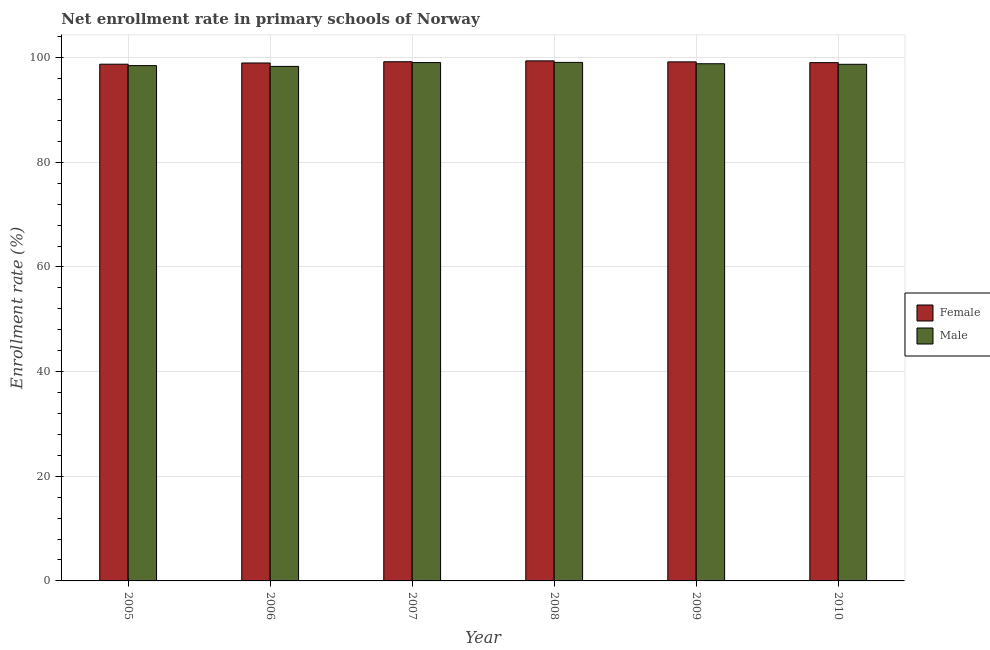How many different coloured bars are there?
Ensure brevity in your answer.  2. What is the enrollment rate of female students in 2006?
Your response must be concise. 98.97. Across all years, what is the maximum enrollment rate of female students?
Your response must be concise. 99.38. Across all years, what is the minimum enrollment rate of male students?
Make the answer very short. 98.32. In which year was the enrollment rate of female students maximum?
Provide a succinct answer. 2008. In which year was the enrollment rate of male students minimum?
Offer a terse response. 2006. What is the total enrollment rate of male students in the graph?
Offer a very short reply. 592.49. What is the difference between the enrollment rate of male students in 2006 and that in 2009?
Your response must be concise. -0.51. What is the difference between the enrollment rate of female students in 2009 and the enrollment rate of male students in 2006?
Offer a very short reply. 0.21. What is the average enrollment rate of male students per year?
Give a very brief answer. 98.75. In the year 2007, what is the difference between the enrollment rate of female students and enrollment rate of male students?
Ensure brevity in your answer.  0. In how many years, is the enrollment rate of male students greater than 60 %?
Offer a terse response. 6. What is the ratio of the enrollment rate of female students in 2005 to that in 2009?
Ensure brevity in your answer.  1. Is the enrollment rate of male students in 2005 less than that in 2010?
Give a very brief answer. Yes. Is the difference between the enrollment rate of female students in 2007 and 2009 greater than the difference between the enrollment rate of male students in 2007 and 2009?
Provide a short and direct response. No. What is the difference between the highest and the second highest enrollment rate of male students?
Offer a terse response. 0.03. What is the difference between the highest and the lowest enrollment rate of male students?
Offer a terse response. 0.76. Is the sum of the enrollment rate of female students in 2005 and 2008 greater than the maximum enrollment rate of male students across all years?
Offer a very short reply. Yes. What does the 2nd bar from the left in 2010 represents?
Your answer should be very brief. Male. What does the 2nd bar from the right in 2005 represents?
Make the answer very short. Female. Are all the bars in the graph horizontal?
Keep it short and to the point. No. Does the graph contain any zero values?
Provide a succinct answer. No. What is the title of the graph?
Provide a short and direct response. Net enrollment rate in primary schools of Norway. What is the label or title of the X-axis?
Make the answer very short. Year. What is the label or title of the Y-axis?
Your answer should be compact. Enrollment rate (%). What is the Enrollment rate (%) of Female in 2005?
Your response must be concise. 98.74. What is the Enrollment rate (%) in Male in 2005?
Ensure brevity in your answer.  98.47. What is the Enrollment rate (%) of Female in 2006?
Make the answer very short. 98.97. What is the Enrollment rate (%) in Male in 2006?
Provide a short and direct response. 98.32. What is the Enrollment rate (%) of Female in 2007?
Offer a very short reply. 99.21. What is the Enrollment rate (%) of Male in 2007?
Make the answer very short. 99.05. What is the Enrollment rate (%) of Female in 2008?
Offer a terse response. 99.38. What is the Enrollment rate (%) of Male in 2008?
Offer a very short reply. 99.09. What is the Enrollment rate (%) in Female in 2009?
Ensure brevity in your answer.  99.19. What is the Enrollment rate (%) of Male in 2009?
Give a very brief answer. 98.83. What is the Enrollment rate (%) in Female in 2010?
Your answer should be very brief. 99.04. What is the Enrollment rate (%) in Male in 2010?
Your answer should be compact. 98.72. Across all years, what is the maximum Enrollment rate (%) of Female?
Ensure brevity in your answer.  99.38. Across all years, what is the maximum Enrollment rate (%) in Male?
Provide a short and direct response. 99.09. Across all years, what is the minimum Enrollment rate (%) in Female?
Provide a short and direct response. 98.74. Across all years, what is the minimum Enrollment rate (%) in Male?
Offer a very short reply. 98.32. What is the total Enrollment rate (%) in Female in the graph?
Keep it short and to the point. 594.53. What is the total Enrollment rate (%) of Male in the graph?
Keep it short and to the point. 592.49. What is the difference between the Enrollment rate (%) of Female in 2005 and that in 2006?
Your answer should be very brief. -0.23. What is the difference between the Enrollment rate (%) of Male in 2005 and that in 2006?
Your answer should be compact. 0.15. What is the difference between the Enrollment rate (%) in Female in 2005 and that in 2007?
Provide a succinct answer. -0.47. What is the difference between the Enrollment rate (%) of Male in 2005 and that in 2007?
Your response must be concise. -0.58. What is the difference between the Enrollment rate (%) of Female in 2005 and that in 2008?
Keep it short and to the point. -0.64. What is the difference between the Enrollment rate (%) of Male in 2005 and that in 2008?
Provide a succinct answer. -0.61. What is the difference between the Enrollment rate (%) in Female in 2005 and that in 2009?
Your answer should be compact. -0.45. What is the difference between the Enrollment rate (%) of Male in 2005 and that in 2009?
Ensure brevity in your answer.  -0.36. What is the difference between the Enrollment rate (%) of Female in 2005 and that in 2010?
Give a very brief answer. -0.3. What is the difference between the Enrollment rate (%) of Male in 2005 and that in 2010?
Your response must be concise. -0.25. What is the difference between the Enrollment rate (%) in Female in 2006 and that in 2007?
Your answer should be very brief. -0.24. What is the difference between the Enrollment rate (%) of Male in 2006 and that in 2007?
Keep it short and to the point. -0.73. What is the difference between the Enrollment rate (%) of Female in 2006 and that in 2008?
Make the answer very short. -0.4. What is the difference between the Enrollment rate (%) in Male in 2006 and that in 2008?
Provide a short and direct response. -0.76. What is the difference between the Enrollment rate (%) in Female in 2006 and that in 2009?
Your response must be concise. -0.21. What is the difference between the Enrollment rate (%) of Male in 2006 and that in 2009?
Offer a terse response. -0.51. What is the difference between the Enrollment rate (%) of Female in 2006 and that in 2010?
Offer a very short reply. -0.07. What is the difference between the Enrollment rate (%) of Male in 2006 and that in 2010?
Your answer should be compact. -0.4. What is the difference between the Enrollment rate (%) in Female in 2007 and that in 2008?
Keep it short and to the point. -0.17. What is the difference between the Enrollment rate (%) in Male in 2007 and that in 2008?
Give a very brief answer. -0.03. What is the difference between the Enrollment rate (%) of Female in 2007 and that in 2009?
Ensure brevity in your answer.  0.02. What is the difference between the Enrollment rate (%) of Male in 2007 and that in 2009?
Your answer should be compact. 0.22. What is the difference between the Enrollment rate (%) of Female in 2007 and that in 2010?
Offer a very short reply. 0.17. What is the difference between the Enrollment rate (%) in Male in 2007 and that in 2010?
Your response must be concise. 0.33. What is the difference between the Enrollment rate (%) of Female in 2008 and that in 2009?
Offer a very short reply. 0.19. What is the difference between the Enrollment rate (%) of Male in 2008 and that in 2009?
Make the answer very short. 0.26. What is the difference between the Enrollment rate (%) in Female in 2008 and that in 2010?
Ensure brevity in your answer.  0.34. What is the difference between the Enrollment rate (%) of Male in 2008 and that in 2010?
Your response must be concise. 0.36. What is the difference between the Enrollment rate (%) of Female in 2009 and that in 2010?
Your answer should be very brief. 0.15. What is the difference between the Enrollment rate (%) of Male in 2009 and that in 2010?
Your answer should be compact. 0.11. What is the difference between the Enrollment rate (%) in Female in 2005 and the Enrollment rate (%) in Male in 2006?
Your response must be concise. 0.42. What is the difference between the Enrollment rate (%) of Female in 2005 and the Enrollment rate (%) of Male in 2007?
Make the answer very short. -0.31. What is the difference between the Enrollment rate (%) in Female in 2005 and the Enrollment rate (%) in Male in 2008?
Give a very brief answer. -0.34. What is the difference between the Enrollment rate (%) in Female in 2005 and the Enrollment rate (%) in Male in 2009?
Offer a very short reply. -0.09. What is the difference between the Enrollment rate (%) in Female in 2005 and the Enrollment rate (%) in Male in 2010?
Your response must be concise. 0.02. What is the difference between the Enrollment rate (%) of Female in 2006 and the Enrollment rate (%) of Male in 2007?
Your answer should be very brief. -0.08. What is the difference between the Enrollment rate (%) in Female in 2006 and the Enrollment rate (%) in Male in 2008?
Offer a very short reply. -0.11. What is the difference between the Enrollment rate (%) in Female in 2006 and the Enrollment rate (%) in Male in 2009?
Provide a short and direct response. 0.14. What is the difference between the Enrollment rate (%) in Female in 2006 and the Enrollment rate (%) in Male in 2010?
Keep it short and to the point. 0.25. What is the difference between the Enrollment rate (%) in Female in 2007 and the Enrollment rate (%) in Male in 2008?
Ensure brevity in your answer.  0.13. What is the difference between the Enrollment rate (%) of Female in 2007 and the Enrollment rate (%) of Male in 2009?
Ensure brevity in your answer.  0.38. What is the difference between the Enrollment rate (%) of Female in 2007 and the Enrollment rate (%) of Male in 2010?
Give a very brief answer. 0.49. What is the difference between the Enrollment rate (%) of Female in 2008 and the Enrollment rate (%) of Male in 2009?
Offer a very short reply. 0.55. What is the difference between the Enrollment rate (%) of Female in 2008 and the Enrollment rate (%) of Male in 2010?
Keep it short and to the point. 0.65. What is the difference between the Enrollment rate (%) of Female in 2009 and the Enrollment rate (%) of Male in 2010?
Give a very brief answer. 0.46. What is the average Enrollment rate (%) of Female per year?
Provide a short and direct response. 99.09. What is the average Enrollment rate (%) of Male per year?
Ensure brevity in your answer.  98.75. In the year 2005, what is the difference between the Enrollment rate (%) of Female and Enrollment rate (%) of Male?
Your answer should be compact. 0.27. In the year 2006, what is the difference between the Enrollment rate (%) in Female and Enrollment rate (%) in Male?
Provide a short and direct response. 0.65. In the year 2007, what is the difference between the Enrollment rate (%) in Female and Enrollment rate (%) in Male?
Make the answer very short. 0.16. In the year 2008, what is the difference between the Enrollment rate (%) in Female and Enrollment rate (%) in Male?
Your response must be concise. 0.29. In the year 2009, what is the difference between the Enrollment rate (%) of Female and Enrollment rate (%) of Male?
Ensure brevity in your answer.  0.36. In the year 2010, what is the difference between the Enrollment rate (%) of Female and Enrollment rate (%) of Male?
Your answer should be very brief. 0.32. What is the ratio of the Enrollment rate (%) in Male in 2005 to that in 2006?
Ensure brevity in your answer.  1. What is the ratio of the Enrollment rate (%) in Male in 2005 to that in 2007?
Provide a short and direct response. 0.99. What is the ratio of the Enrollment rate (%) in Female in 2005 to that in 2008?
Your answer should be very brief. 0.99. What is the ratio of the Enrollment rate (%) in Male in 2005 to that in 2008?
Make the answer very short. 0.99. What is the ratio of the Enrollment rate (%) of Female in 2005 to that in 2009?
Provide a succinct answer. 1. What is the ratio of the Enrollment rate (%) of Male in 2005 to that in 2009?
Provide a short and direct response. 1. What is the ratio of the Enrollment rate (%) of Female in 2005 to that in 2010?
Your answer should be very brief. 1. What is the ratio of the Enrollment rate (%) in Male in 2006 to that in 2007?
Your response must be concise. 0.99. What is the ratio of the Enrollment rate (%) in Male in 2006 to that in 2008?
Give a very brief answer. 0.99. What is the ratio of the Enrollment rate (%) in Male in 2006 to that in 2009?
Offer a very short reply. 0.99. What is the ratio of the Enrollment rate (%) in Male in 2006 to that in 2010?
Keep it short and to the point. 1. What is the ratio of the Enrollment rate (%) of Female in 2007 to that in 2009?
Ensure brevity in your answer.  1. What is the ratio of the Enrollment rate (%) in Female in 2007 to that in 2010?
Give a very brief answer. 1. What is the ratio of the Enrollment rate (%) in Male in 2008 to that in 2009?
Ensure brevity in your answer.  1. What is the ratio of the Enrollment rate (%) of Female in 2008 to that in 2010?
Your answer should be very brief. 1. What is the ratio of the Enrollment rate (%) in Male in 2008 to that in 2010?
Your answer should be compact. 1. What is the difference between the highest and the second highest Enrollment rate (%) of Female?
Keep it short and to the point. 0.17. What is the difference between the highest and the second highest Enrollment rate (%) in Male?
Offer a very short reply. 0.03. What is the difference between the highest and the lowest Enrollment rate (%) in Female?
Ensure brevity in your answer.  0.64. What is the difference between the highest and the lowest Enrollment rate (%) in Male?
Your answer should be very brief. 0.76. 